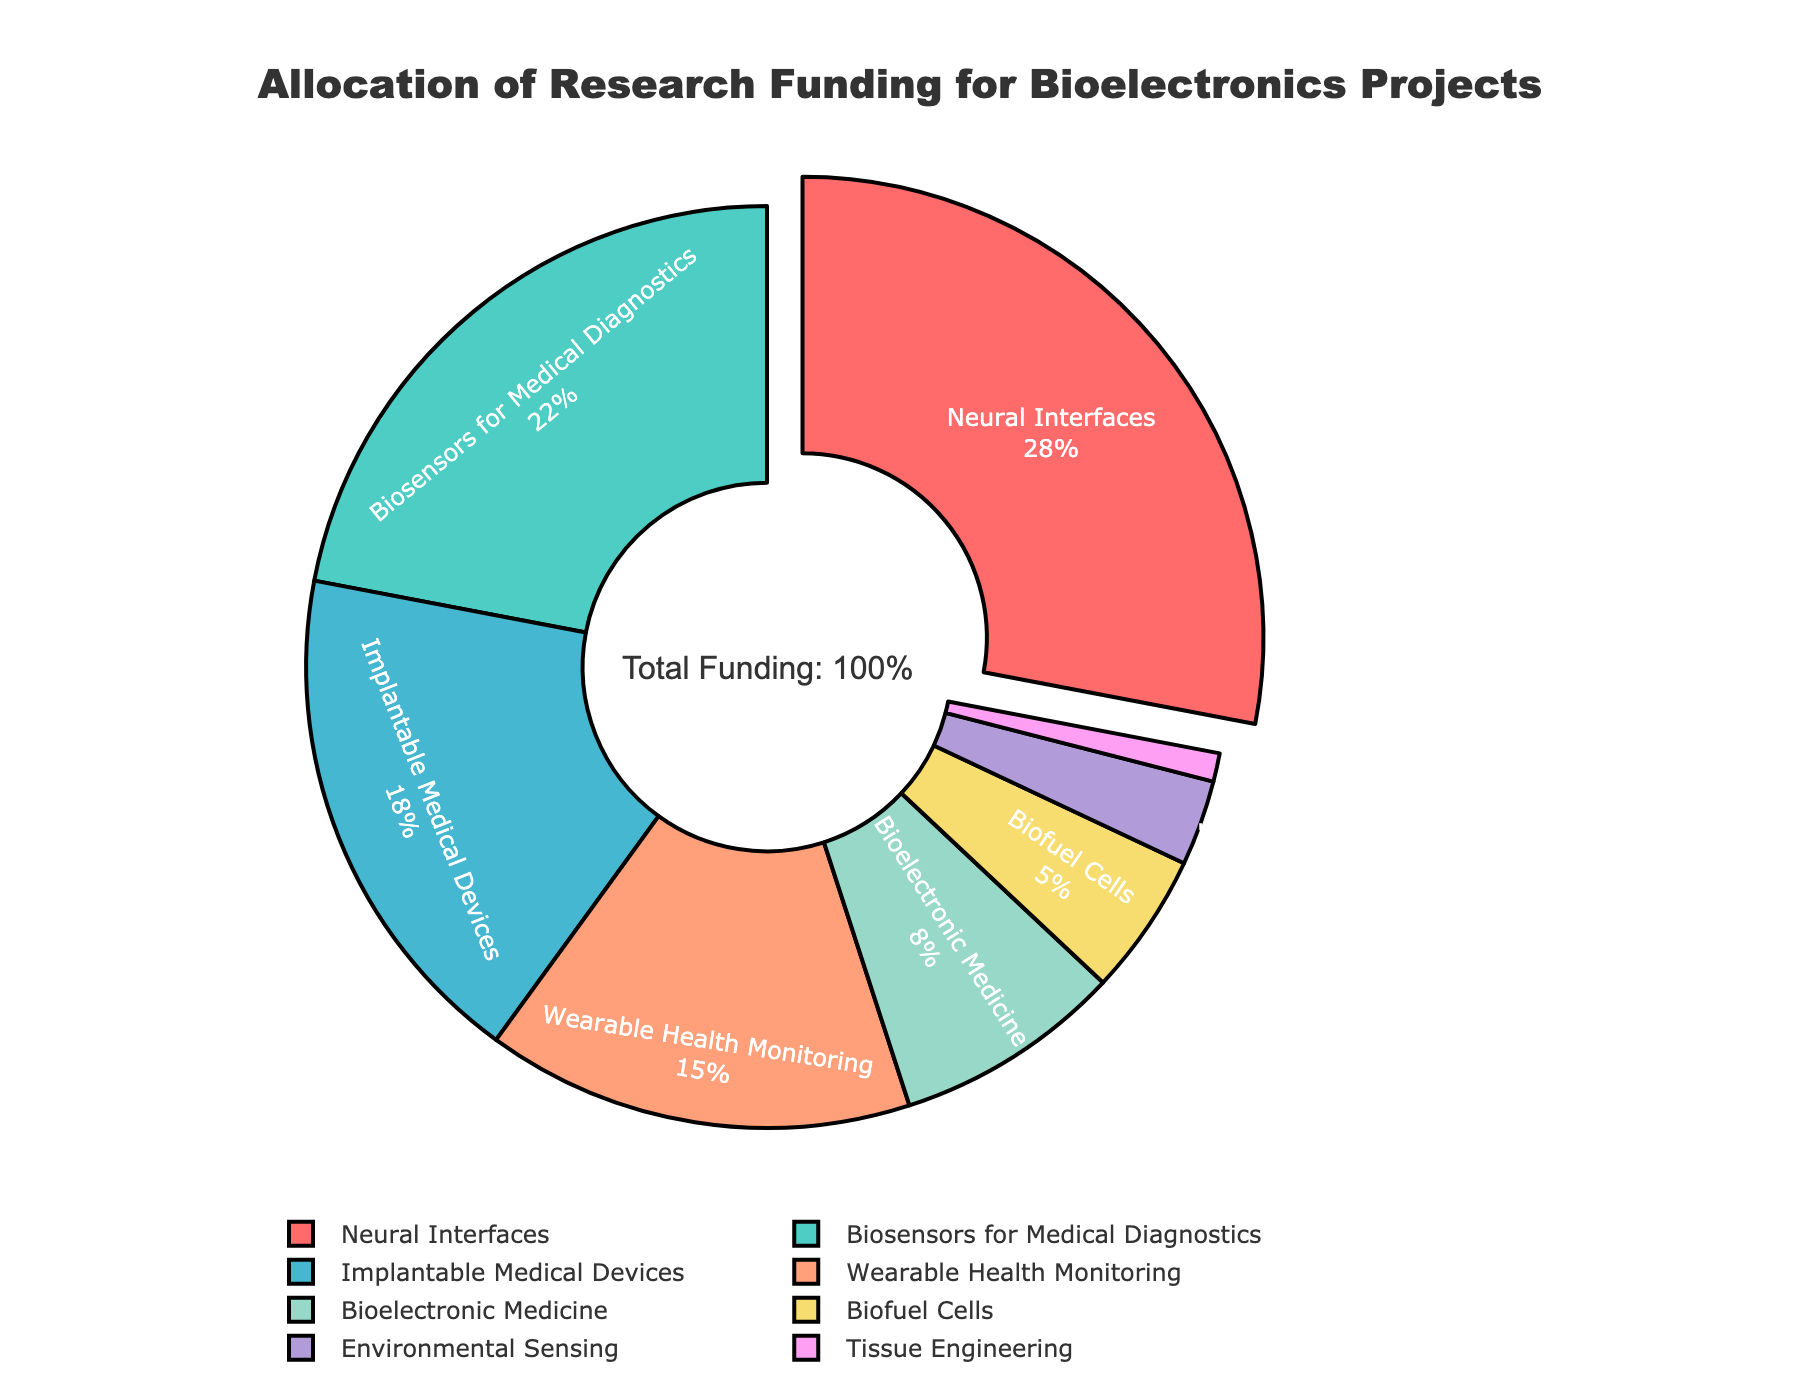What percentage of the funding is allocated to Neural Interfaces? Neural Interfaces have a percentage label on the chart.
Answer: 28% How much more funding is allocated to Biosensors for Medical Diagnostics compared to Biofuel Cells? Biosensors for Medical Diagnostics receive 22%, and Biofuel Cells receive 5%. The difference is 22% - 5% = 17%.
Answer: 17% Which application area receives the least funding? The area with the smallest segment on the pie chart and an identified label of 1% is Tissue Engineering.
Answer: Tissue Engineering What is the total percentage of funding allocated to Implantable Medical Devices and Wearable Health Monitoring combined? Implantable Medical Devices receive 18%, and Wearable Health Monitoring receives 15%. The sum is 18% + 15% = 33%.
Answer: 33% Which application area receives less funding: Bioelectronic Medicine or Environmental Sensing? Bioelectronic Medicine receives 8%, while Environmental Sensing receives 3%. 3% is less than 8%.
Answer: Environmental Sensing Are Neural Interfaces funded more than double the amount of Biofuel Cells? Neural Interfaces receive 28% funding, while Biofuel Cells get 5%. Doubling Biofuel Cells' funding is 5% * 2 = 10%. Since 28% is greater than 10%, Neural Interfaces receive more than double.
Answer: Yes What percentage of total funding is allocated to application areas other than Neural Interfaces and Biosensors for Medical Diagnostics? Neural Interfaces and Biosensors for Medical Diagnostics together get 28% + 22% = 50%. Subtracting from 100%, 100% - 50% = 50%.
Answer: 50% Among the application areas, which has the closest funding percentage to Bioelectronic Medicine? Bioelectronic Medicine has 8%. Comparing with others: Neural Interfaces (28%), Biosensors for Medical Diagnostics (22%), Implantable Medical Devices (18%), Wearable Health Monitoring (15%), Biofuel Cells (5%), Environmental Sensing (3%), Tissue Engineering (1%). Biofuel Cells at 5% is the closest.
Answer: Biofuel Cells 